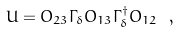Convert formula to latex. <formula><loc_0><loc_0><loc_500><loc_500>U = O _ { 2 3 } \Gamma _ { \delta } O _ { 1 3 } \Gamma _ { \delta } ^ { \dagger } O _ { 1 2 } \ ,</formula> 